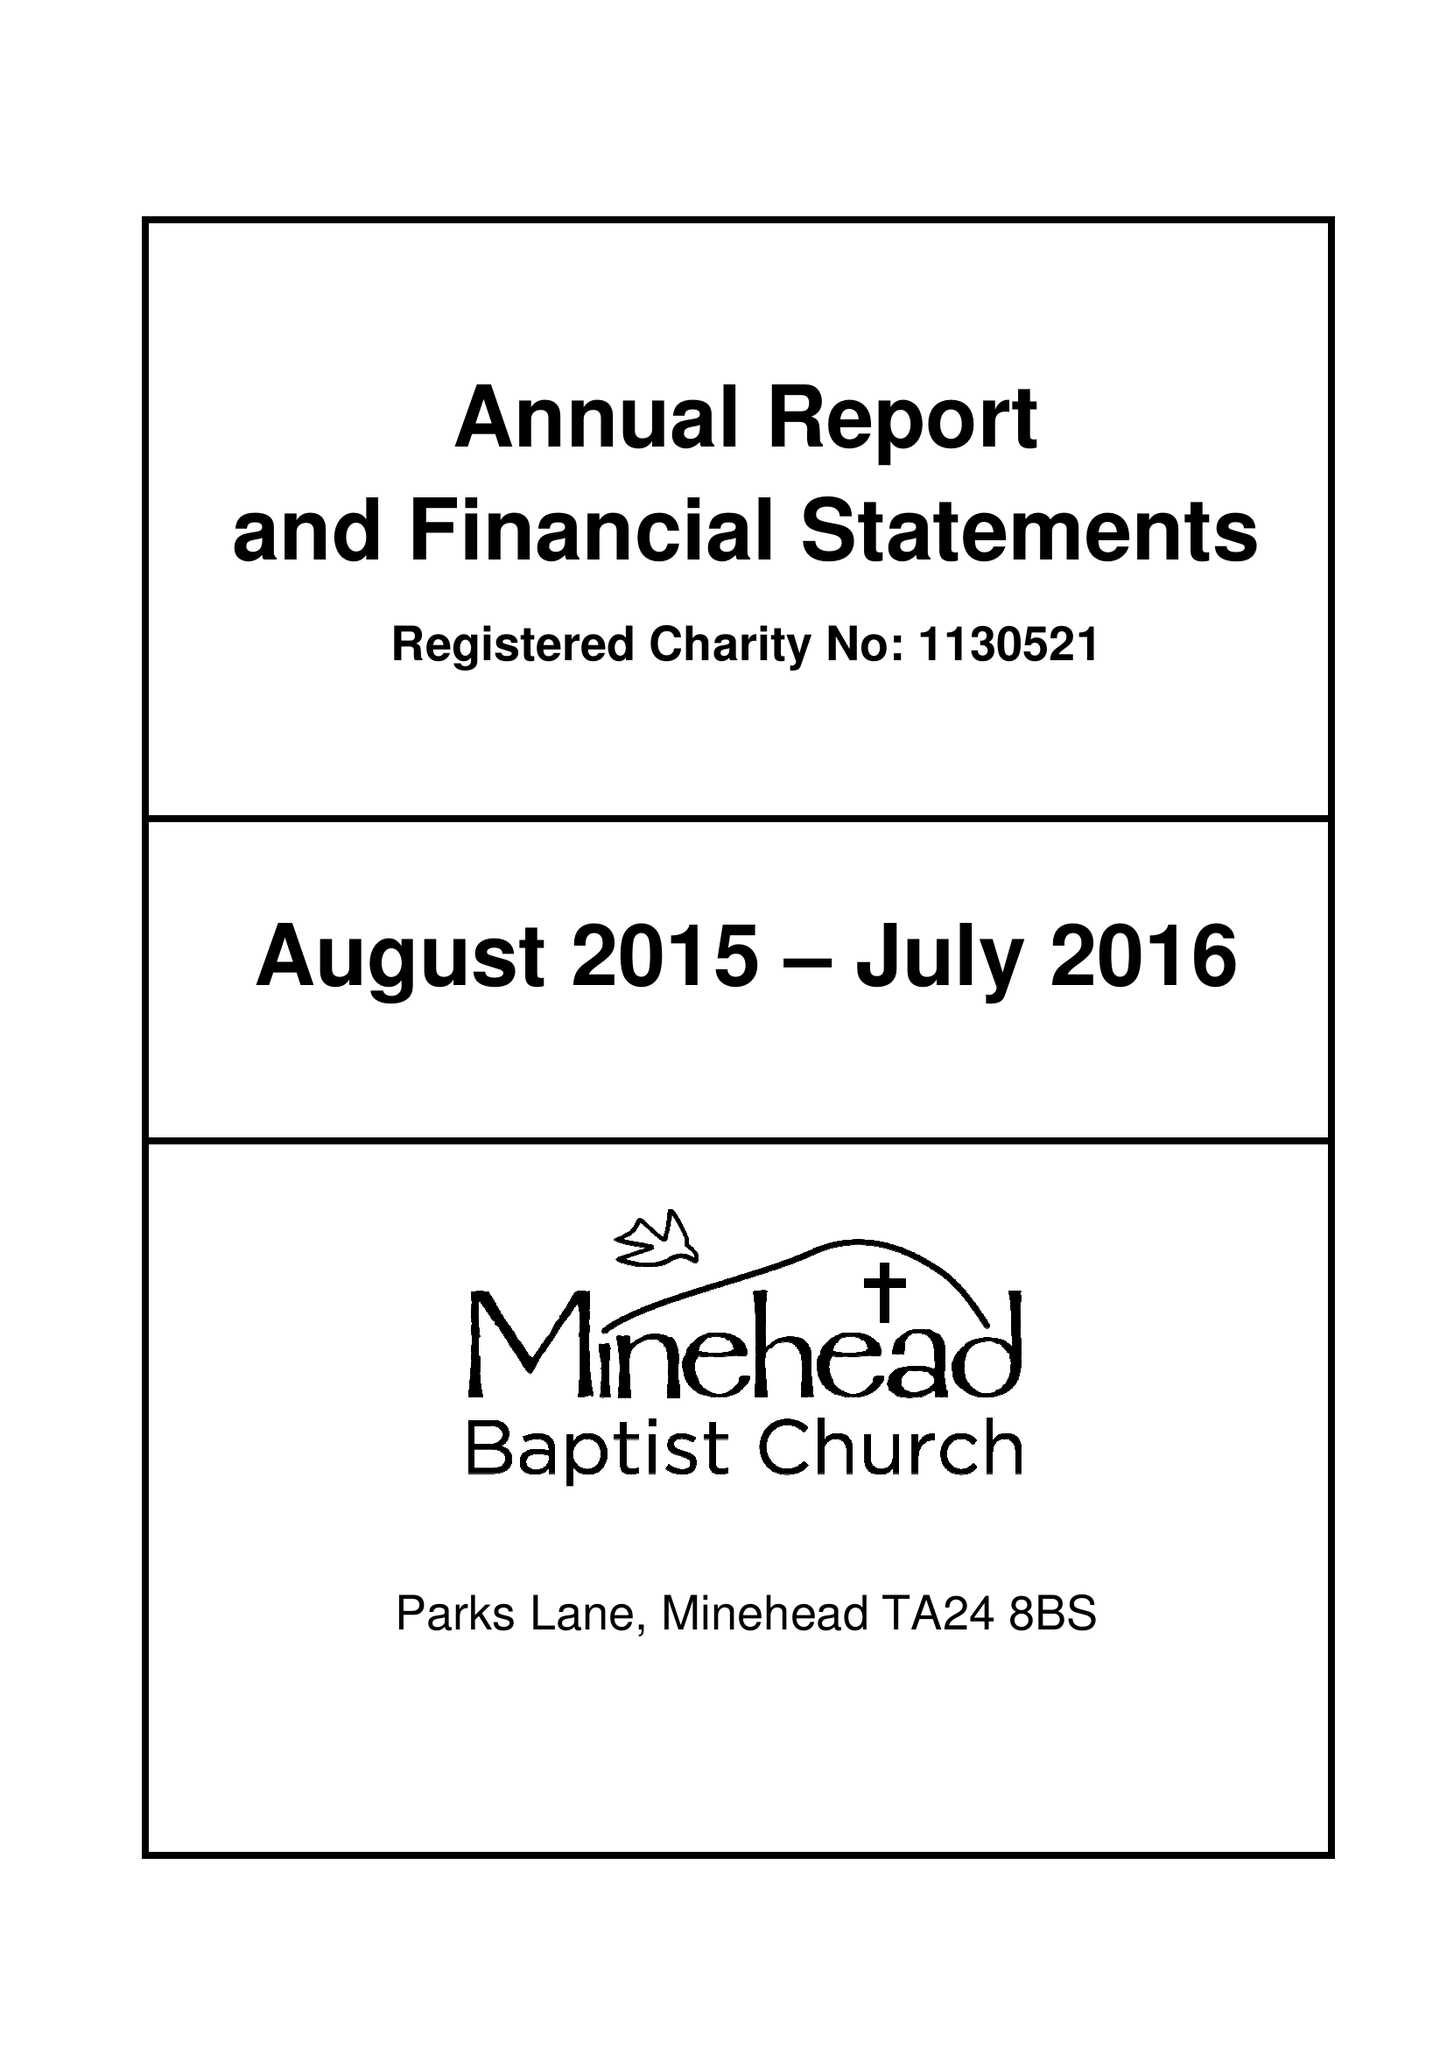What is the value for the address__street_line?
Answer the question using a single word or phrase. THE PARKS 